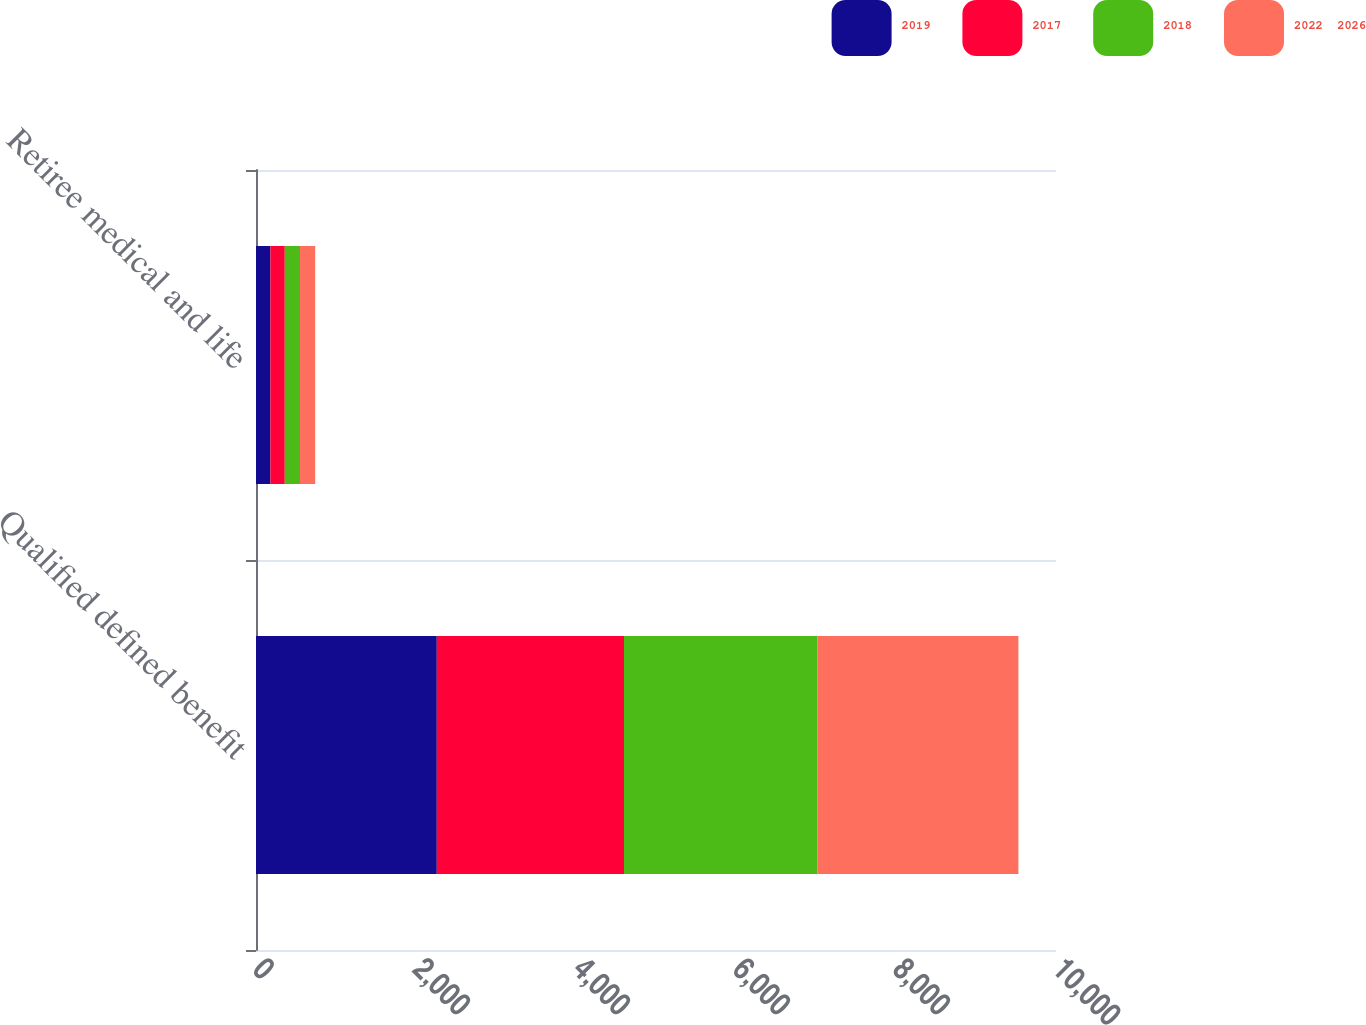<chart> <loc_0><loc_0><loc_500><loc_500><stacked_bar_chart><ecel><fcel>Qualified defined benefit<fcel>Retiree medical and life<nl><fcel>2019<fcel>2260<fcel>180<nl><fcel>2017<fcel>2340<fcel>180<nl><fcel>2018<fcel>2420<fcel>190<nl><fcel>2022  2026<fcel>2510<fcel>190<nl></chart> 